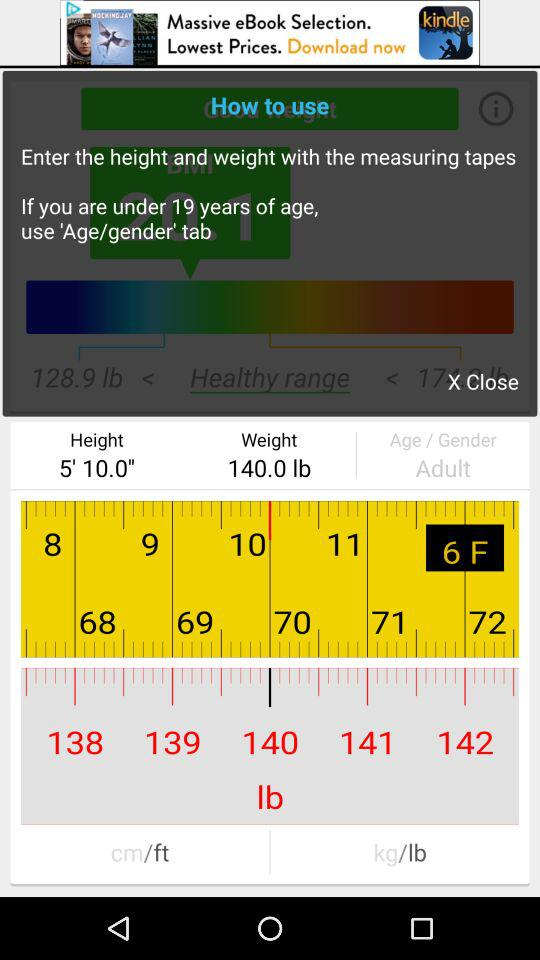What is the age of the person?
Answer the question using a single word or phrase. Adult 